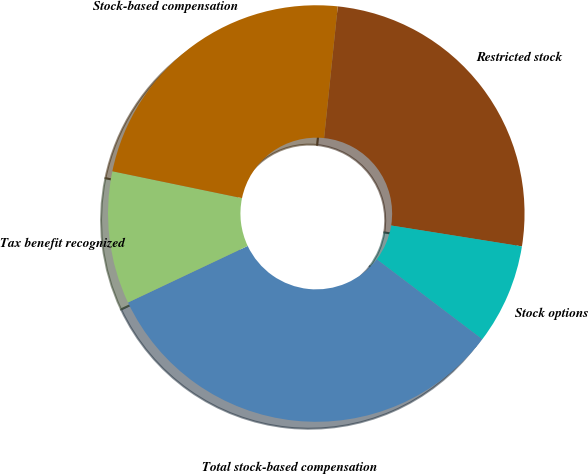Convert chart to OTSL. <chart><loc_0><loc_0><loc_500><loc_500><pie_chart><fcel>Restricted stock<fcel>Stock options<fcel>Total stock-based compensation<fcel>Tax benefit recognized<fcel>Stock-based compensation<nl><fcel>25.88%<fcel>7.8%<fcel>32.65%<fcel>10.28%<fcel>23.39%<nl></chart> 